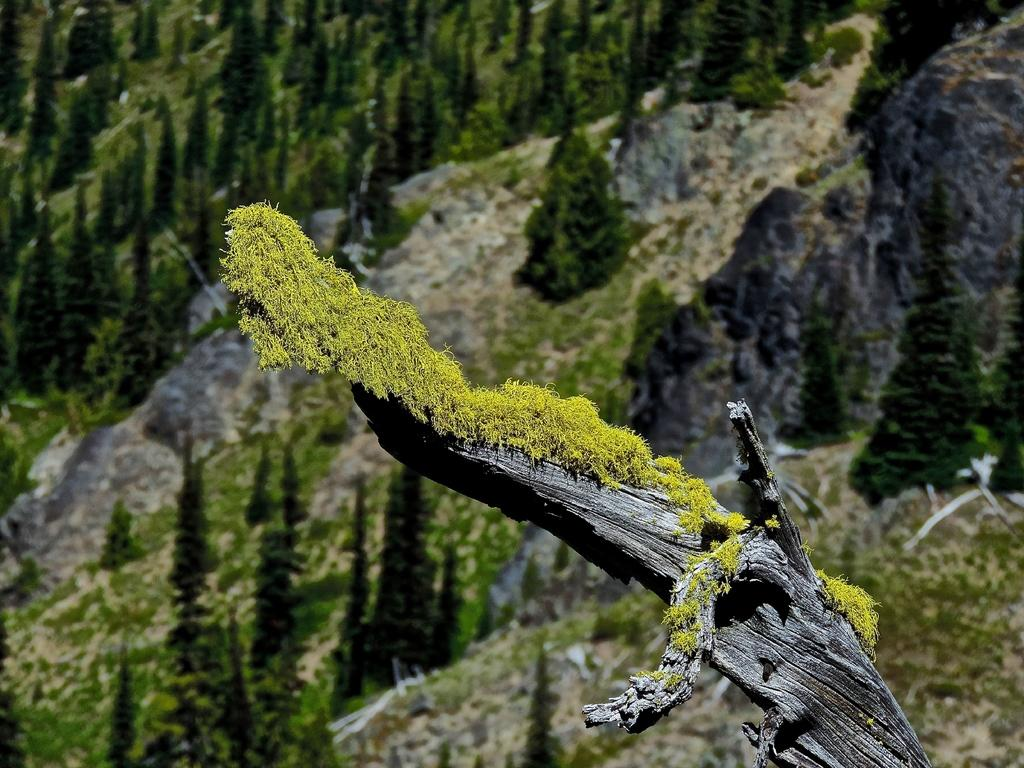What is the main subject of the image? The main subject of the image is a tree trunk. What can be observed on the tree trunk? Mosses are present on the tree trunk. What is the surrounding environment like? There are trees surrounding the tree trunk, and there are plants in the vicinity. What type of cake is being served at the news conference in the image? There is no cake or news conference present in the image; it features a tree trunk with mosses and surrounding trees and plants. 